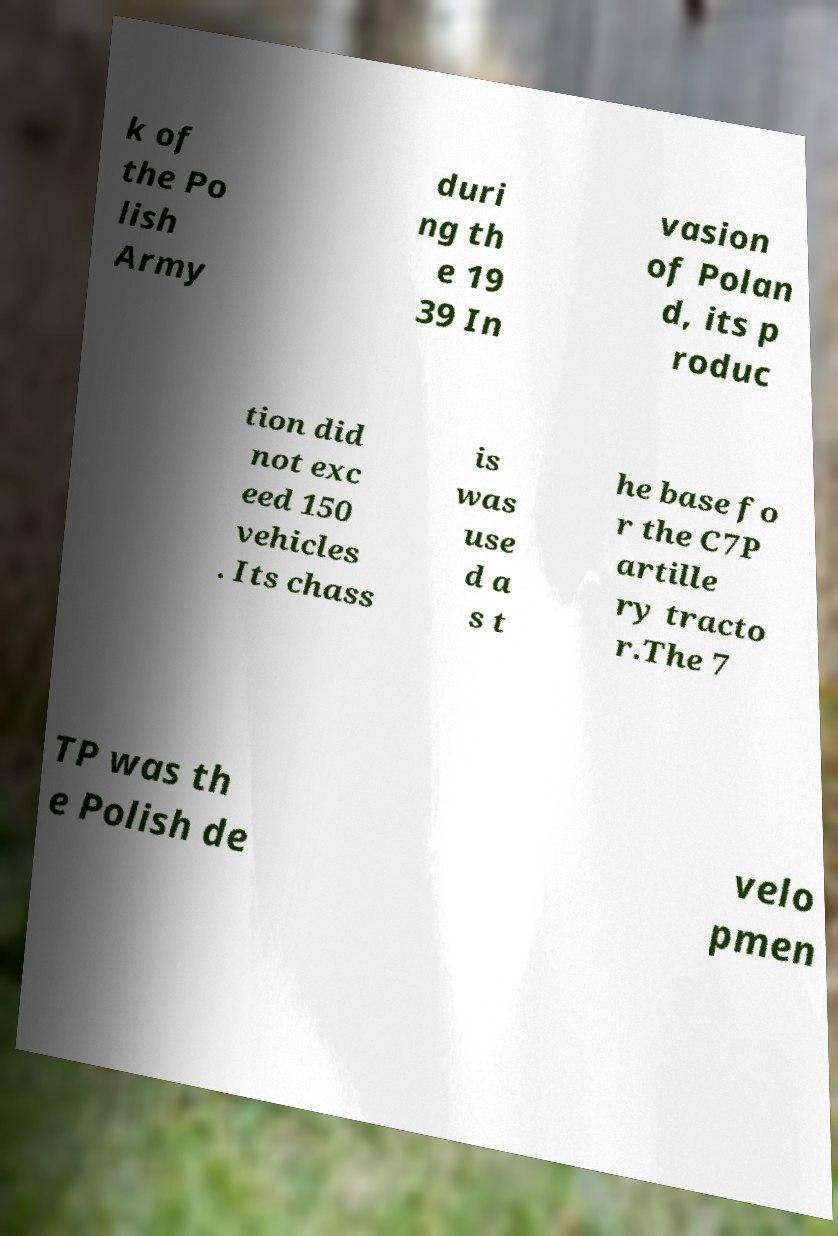Could you assist in decoding the text presented in this image and type it out clearly? k of the Po lish Army duri ng th e 19 39 In vasion of Polan d, its p roduc tion did not exc eed 150 vehicles . Its chass is was use d a s t he base fo r the C7P artille ry tracto r.The 7 TP was th e Polish de velo pmen 